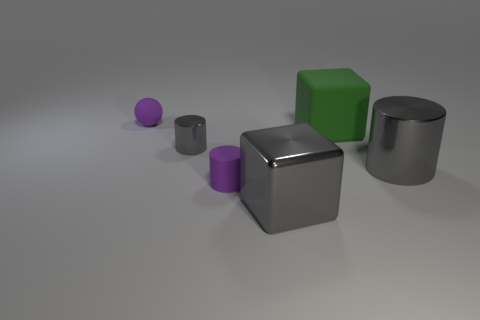Is the size of the sphere the same as the rubber cylinder?
Make the answer very short. Yes. How many large green blocks are the same material as the gray cube?
Provide a short and direct response. 0. What size is the rubber object that is the same shape as the tiny gray metallic thing?
Your answer should be compact. Small. Do the large metallic thing right of the big gray shiny block and the small gray metal thing have the same shape?
Your response must be concise. Yes. What shape is the matte thing right of the big metal thing left of the large matte thing?
Your answer should be very brief. Cube. There is another metallic thing that is the same shape as the green thing; what is its color?
Offer a very short reply. Gray. Does the large metal block have the same color as the metal object on the right side of the large green object?
Offer a terse response. Yes. What is the shape of the matte object that is both behind the purple cylinder and left of the gray cube?
Make the answer very short. Sphere. Is the number of green rubber blocks less than the number of big blocks?
Provide a short and direct response. Yes. Is there a cyan thing?
Provide a succinct answer. No. 